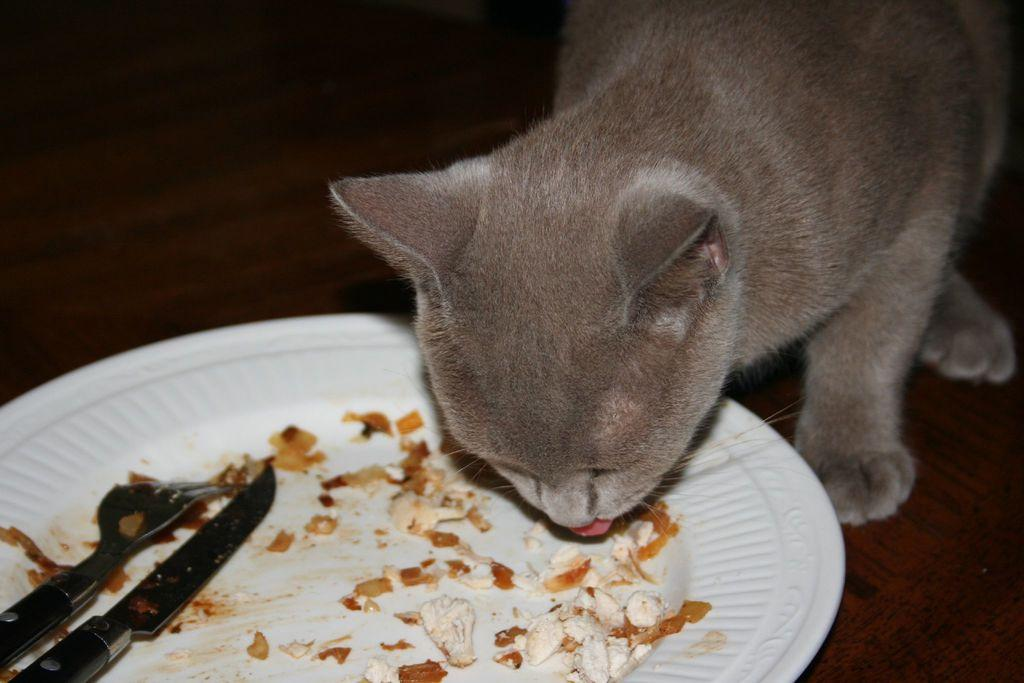What animal can be seen in the image? There is a cat in the image. What is the cat doing in the image? The cat is eating food in the image. Where is the food located? The food is in a plate in the image. What utensil is present in the plate with the food? There is a knife in the plate with the food. Are there any other plates visible in the image? Yes, there is another plate beside the first plate in the image. What type of friction can be observed between the cat and the plate in the image? There is no friction between the cat and the plate in the image; the cat is simply eating food from the plate. What color is the orange in the image? There is no orange present in the image. 